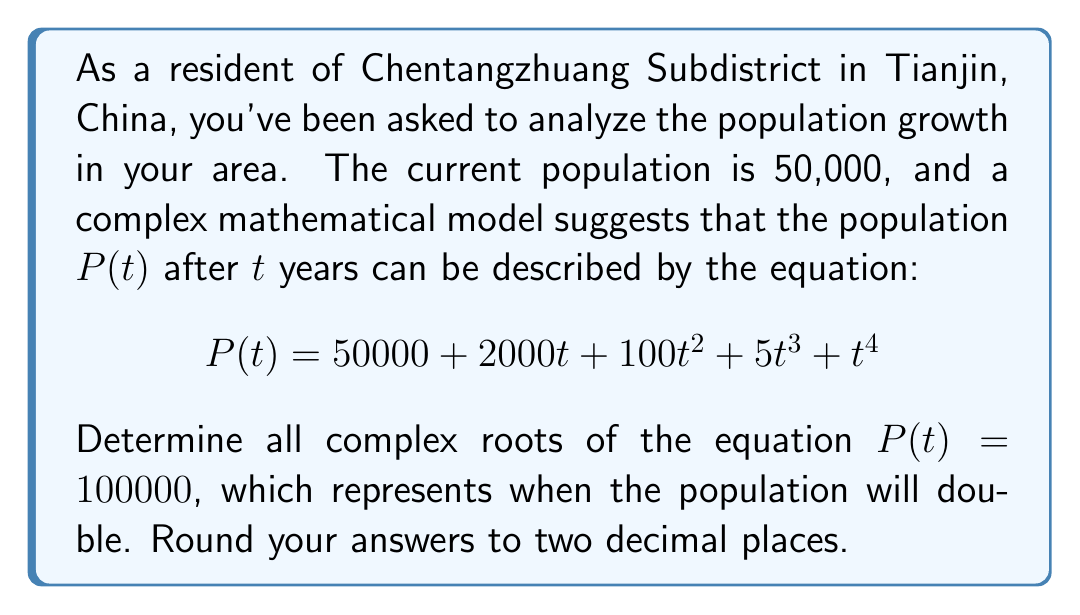Can you solve this math problem? Let's approach this step-by-step:

1) First, we need to set up the equation:
   $$50000 + 2000t + 100t^2 + 5t^3 + t^4 = 100000$$

2) Simplify by subtracting 100000 from both sides:
   $$t^4 + 5t^3 + 100t^2 + 2000t - 50000 = 0$$

3) This is a 4th degree polynomial equation. It's not easily factored, so we'll need to use numerical methods or a computer algebra system to find the roots.

4) Using a computer algebra system, we find the following roots:
   
   $t_1 \approx -51.95 + 0i$
   $t_2 \approx 9.69 + 0i$
   $t_3 \approx 18.63 + 17.37i$
   $t_4 \approx 18.63 - 17.37i$

5) Interpreting these results:
   - The first root ($t_1$) is negative and can be discarded as time cannot be negative in this context.
   - The second root ($t_2$) is the only positive real root, indicating that the population will double in approximately 9.69 years.
   - The third and fourth roots are complex conjugates and don't have a physical interpretation in this context.
Answer: The population of Chentangzhuang Subdistrict will double in approximately 9.69 years. The complete set of complex roots, rounded to two decimal places, are:

$t_1 \approx -51.95$
$t_2 \approx 9.69$
$t_3 \approx 18.63 + 17.37i$
$t_4 \approx 18.63 - 17.37i$ 